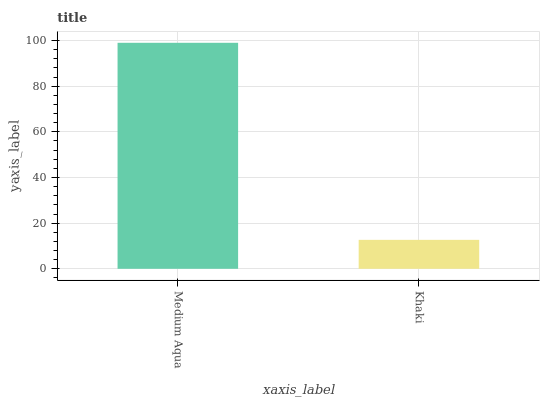Is Khaki the minimum?
Answer yes or no. Yes. Is Medium Aqua the maximum?
Answer yes or no. Yes. Is Khaki the maximum?
Answer yes or no. No. Is Medium Aqua greater than Khaki?
Answer yes or no. Yes. Is Khaki less than Medium Aqua?
Answer yes or no. Yes. Is Khaki greater than Medium Aqua?
Answer yes or no. No. Is Medium Aqua less than Khaki?
Answer yes or no. No. Is Medium Aqua the high median?
Answer yes or no. Yes. Is Khaki the low median?
Answer yes or no. Yes. Is Khaki the high median?
Answer yes or no. No. Is Medium Aqua the low median?
Answer yes or no. No. 